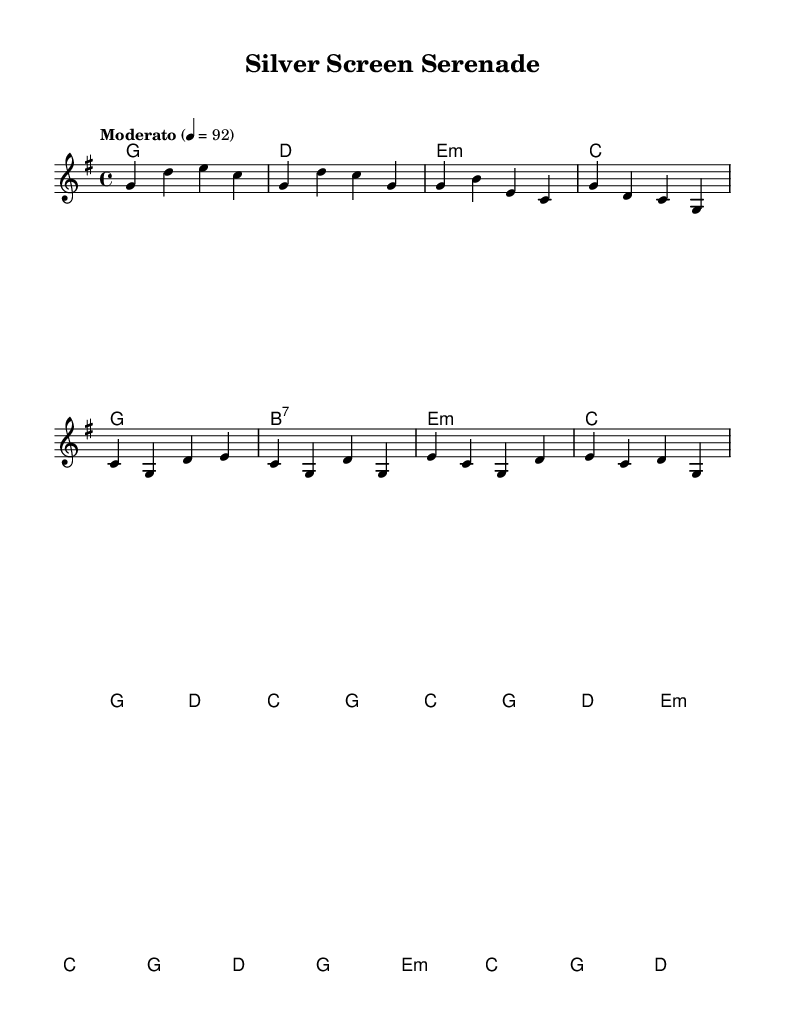What is the key signature of this music? The key signature indicated is G major, which has one sharp (F#).
Answer: G major What is the time signature of this music? The time signature shown is 4/4, which means there are four beats in each measure and the quarter note gets one beat.
Answer: 4/4 What is the tempo marking for this piece? The tempo marking indicates a "Moderato" speed, set at a metronome marking of 92 beats per minute.
Answer: Moderato How many measures are in the Chorus section? Counting the measures in the Chorus, there are six measures as indicated by the grouping of the notes in that section.
Answer: 6 What is the dominant chord noted in the melody during the Verse? The dominant chord in the key of G major is D major, which is noted during the Verse section of the sheet music.
Answer: D What is the structure of the piece based on the sections provided? The structure consists of an Intro, Verse, Chorus, and a Bridge, showcasing a clear narrative flow typical in contemporary country music.
Answer: Intro, Verse, Chorus, Bridge Which instruments are typically used to perform this piece in a contemporary country setting? While the sheet music does not explicitly state instruments, contemporary country typically includes guitar, bass, and sometimes strings, which align with the dramatic instrumental style.
Answer: Guitar, bass, strings 